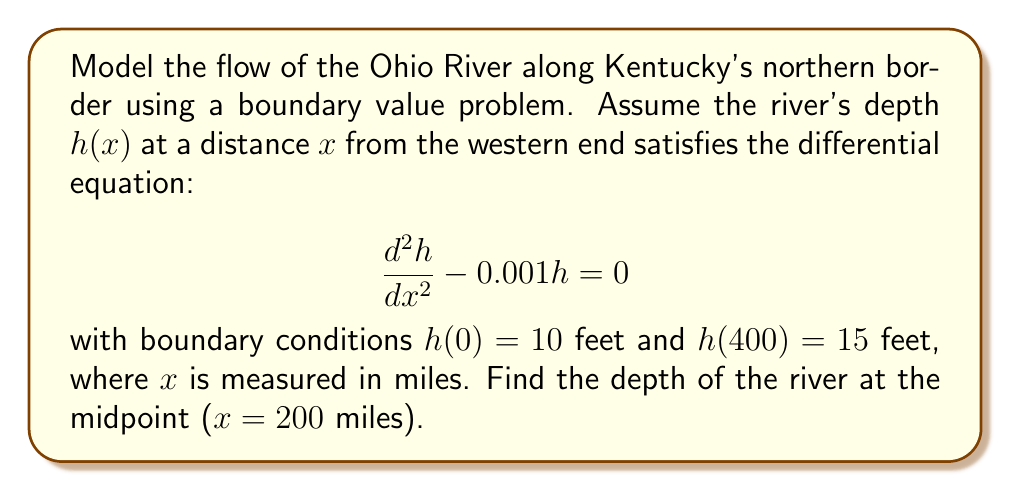Can you solve this math problem? Let's solve this boundary value problem step-by-step:

1) The general solution to the differential equation $\frac{d^2h}{dx^2} - 0.001h = 0$ is:

   $$h(x) = C_1e^{\sqrt{0.001}x} + C_2e^{-\sqrt{0.001}x}$$

2) Let $k = \sqrt{0.001} \approx 0.0316228$. Our solution becomes:

   $$h(x) = C_1e^{kx} + C_2e^{-kx}$$

3) Apply the boundary conditions:

   At $x = 0$: $h(0) = 10 = C_1 + C_2$
   At $x = 400$: $h(400) = 15 = C_1e^{400k} + C_2e^{-400k}$

4) Solve this system of equations:

   $C_1 + C_2 = 10$
   $C_1e^{400k} + C_2e^{-400k} = 15$

5) Subtract the first equation from the second:

   $C_1(e^{400k} - 1) + C_2(e^{-400k} - 1) = 5$

6) Substitute $C_2 = 10 - C_1$ from the first equation:

   $C_1(e^{400k} - 1) + (10 - C_1)(e^{-400k} - 1) = 5$

7) Solve for $C_1$:

   $C_1 = \frac{5 + 10(1 - e^{-400k})}{e^{400k} - e^{-400k}} \approx 4.9999$

8) Then $C_2 = 10 - C_1 \approx 5.0001$

9) Now we can find the depth at $x = 200$ miles:

   $$h(200) = C_1e^{200k} + C_2e^{-200k}$$

10) Substitute the values and calculate:

    $$h(200) \approx 4.9999e^{200 \cdot 0.0316228} + 5.0001e^{-200 \cdot 0.0316228} \approx 12.5$$
Answer: 12.5 feet 